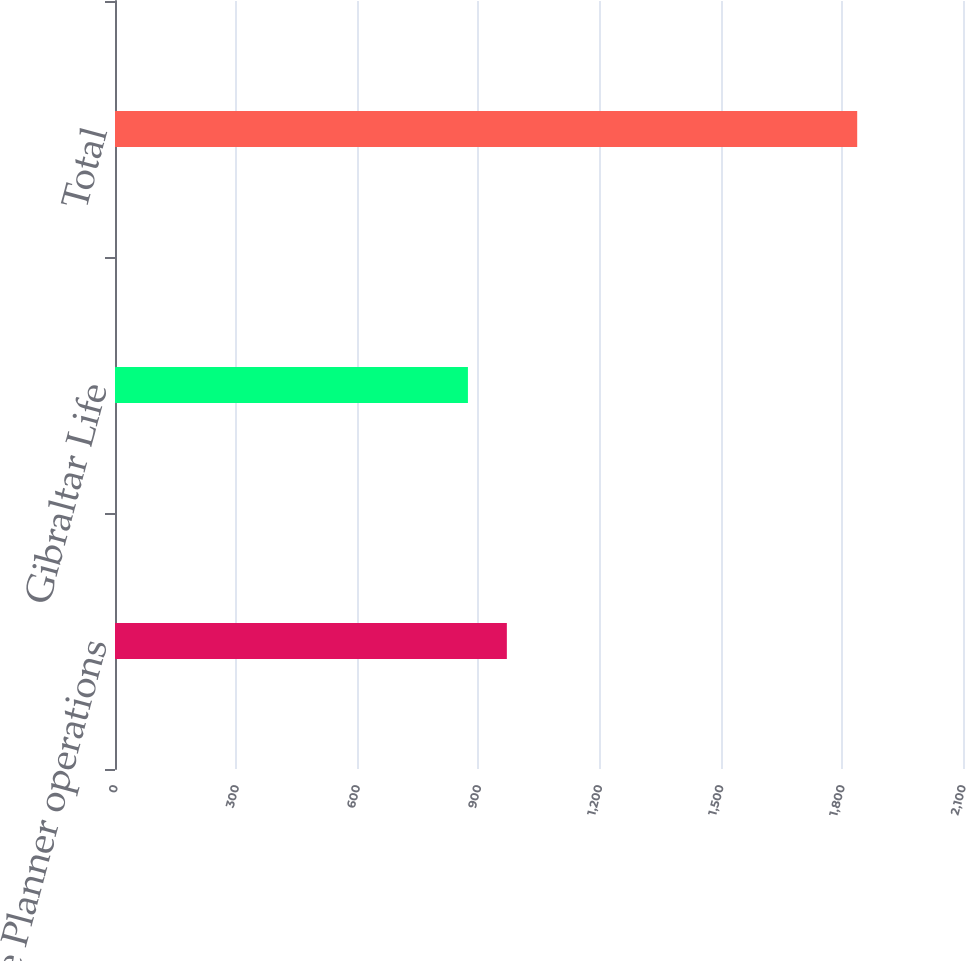Convert chart to OTSL. <chart><loc_0><loc_0><loc_500><loc_500><bar_chart><fcel>Life Planner operations<fcel>Gibraltar Life<fcel>Total<nl><fcel>970.4<fcel>874<fcel>1838<nl></chart> 